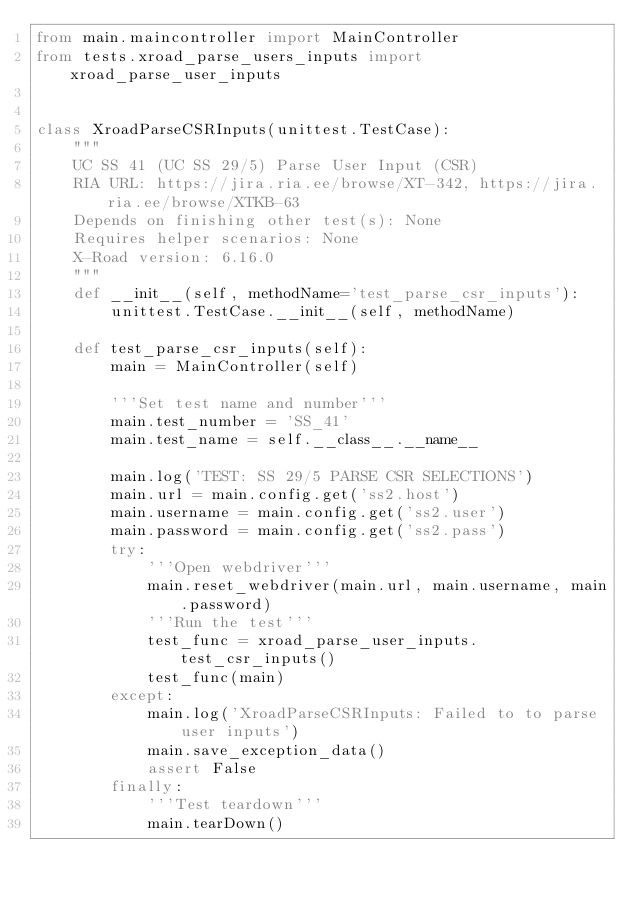Convert code to text. <code><loc_0><loc_0><loc_500><loc_500><_Python_>from main.maincontroller import MainController
from tests.xroad_parse_users_inputs import xroad_parse_user_inputs


class XroadParseCSRInputs(unittest.TestCase):
    """
    UC SS 41 (UC SS 29/5) Parse User Input (CSR)
    RIA URL: https://jira.ria.ee/browse/XT-342, https://jira.ria.ee/browse/XTKB-63
    Depends on finishing other test(s): None
    Requires helper scenarios: None
    X-Road version: 6.16.0
    """
    def __init__(self, methodName='test_parse_csr_inputs'):
        unittest.TestCase.__init__(self, methodName)

    def test_parse_csr_inputs(self):
        main = MainController(self)

        '''Set test name and number'''
        main.test_number = 'SS_41'
        main.test_name = self.__class__.__name__

        main.log('TEST: SS 29/5 PARSE CSR SELECTIONS')
        main.url = main.config.get('ss2.host')
        main.username = main.config.get('ss2.user')
        main.password = main.config.get('ss2.pass')
        try:
            '''Open webdriver'''
            main.reset_webdriver(main.url, main.username, main.password)
            '''Run the test'''
            test_func = xroad_parse_user_inputs.test_csr_inputs()
            test_func(main)
        except:
            main.log('XroadParseCSRInputs: Failed to to parse user inputs')
            main.save_exception_data()
            assert False
        finally:
            '''Test teardown'''
            main.tearDown()
</code> 